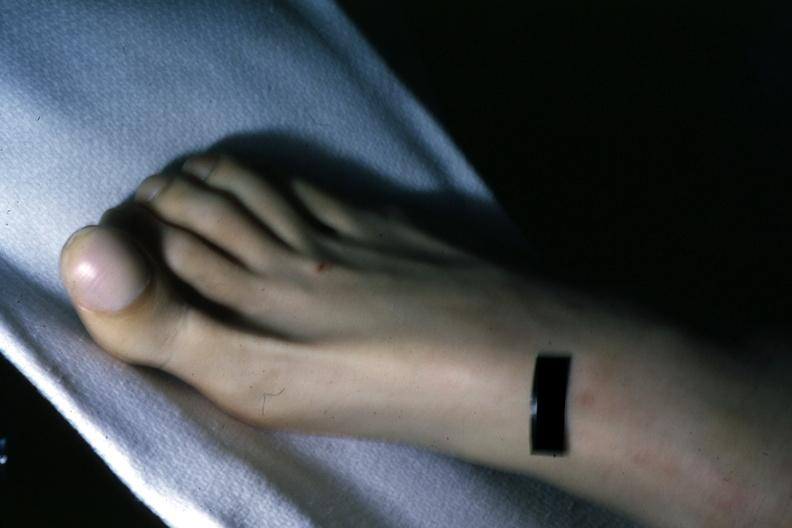s case of peritonitis slide present?
Answer the question using a single word or phrase. No 